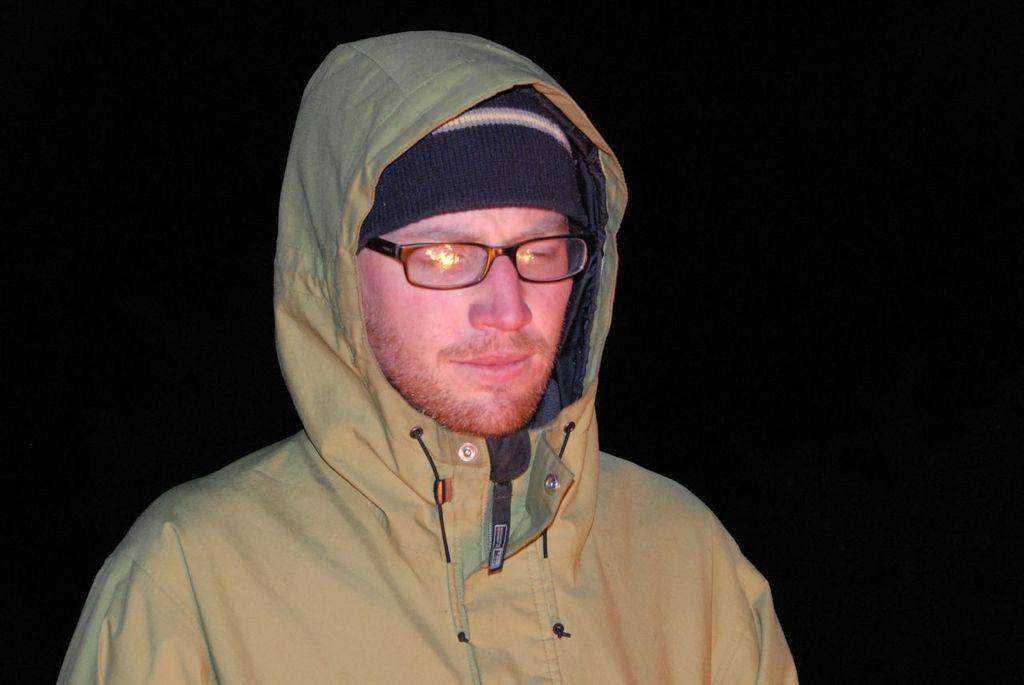How many people are present in the image? There is one person in the image. What type of coat is the person wearing in the image? There is no information about a coat in the image, as only the presence of one person is mentioned. 